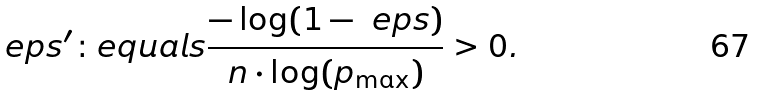<formula> <loc_0><loc_0><loc_500><loc_500>\ e p s ^ { \prime } \colon e q u a l s \frac { - \log ( 1 - \ e p s ) } { n \cdot \log ( p _ { \max } ) } > 0 .</formula> 